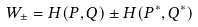<formula> <loc_0><loc_0><loc_500><loc_500>W _ { \pm } = H ( P , Q ) \pm H ( P ^ { * } , Q ^ { * } )</formula> 